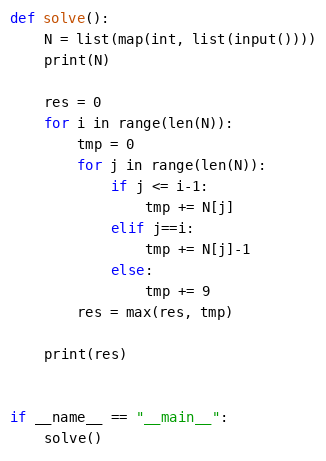<code> <loc_0><loc_0><loc_500><loc_500><_Python_>def solve():
    N = list(map(int, list(input())))
    print(N)

    res = 0
    for i in range(len(N)):
        tmp = 0
        for j in range(len(N)):
            if j <= i-1:
                tmp += N[j]
            elif j==i:
                tmp += N[j]-1
            else:
                tmp += 9
        res = max(res, tmp)

    print(res)


if __name__ == "__main__":
    solve()


</code> 